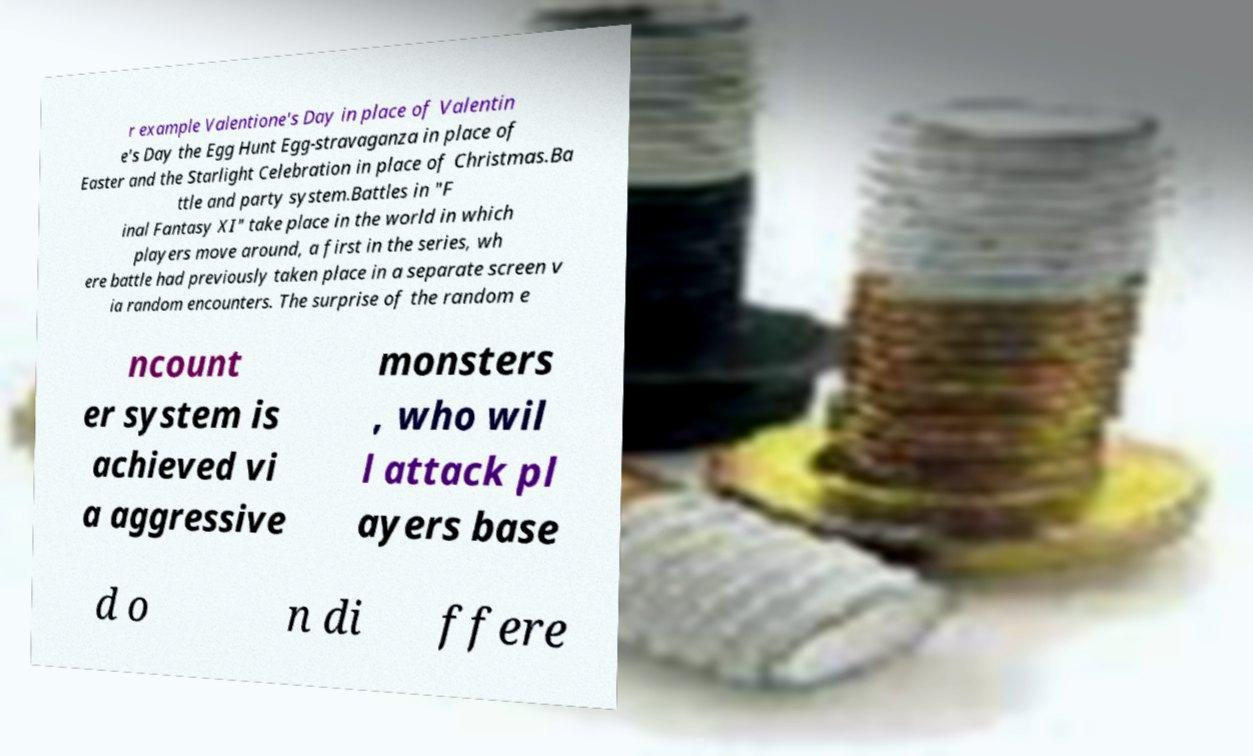Please read and relay the text visible in this image. What does it say? r example Valentione's Day in place of Valentin e's Day the Egg Hunt Egg-stravaganza in place of Easter and the Starlight Celebration in place of Christmas.Ba ttle and party system.Battles in "F inal Fantasy XI" take place in the world in which players move around, a first in the series, wh ere battle had previously taken place in a separate screen v ia random encounters. The surprise of the random e ncount er system is achieved vi a aggressive monsters , who wil l attack pl ayers base d o n di ffere 